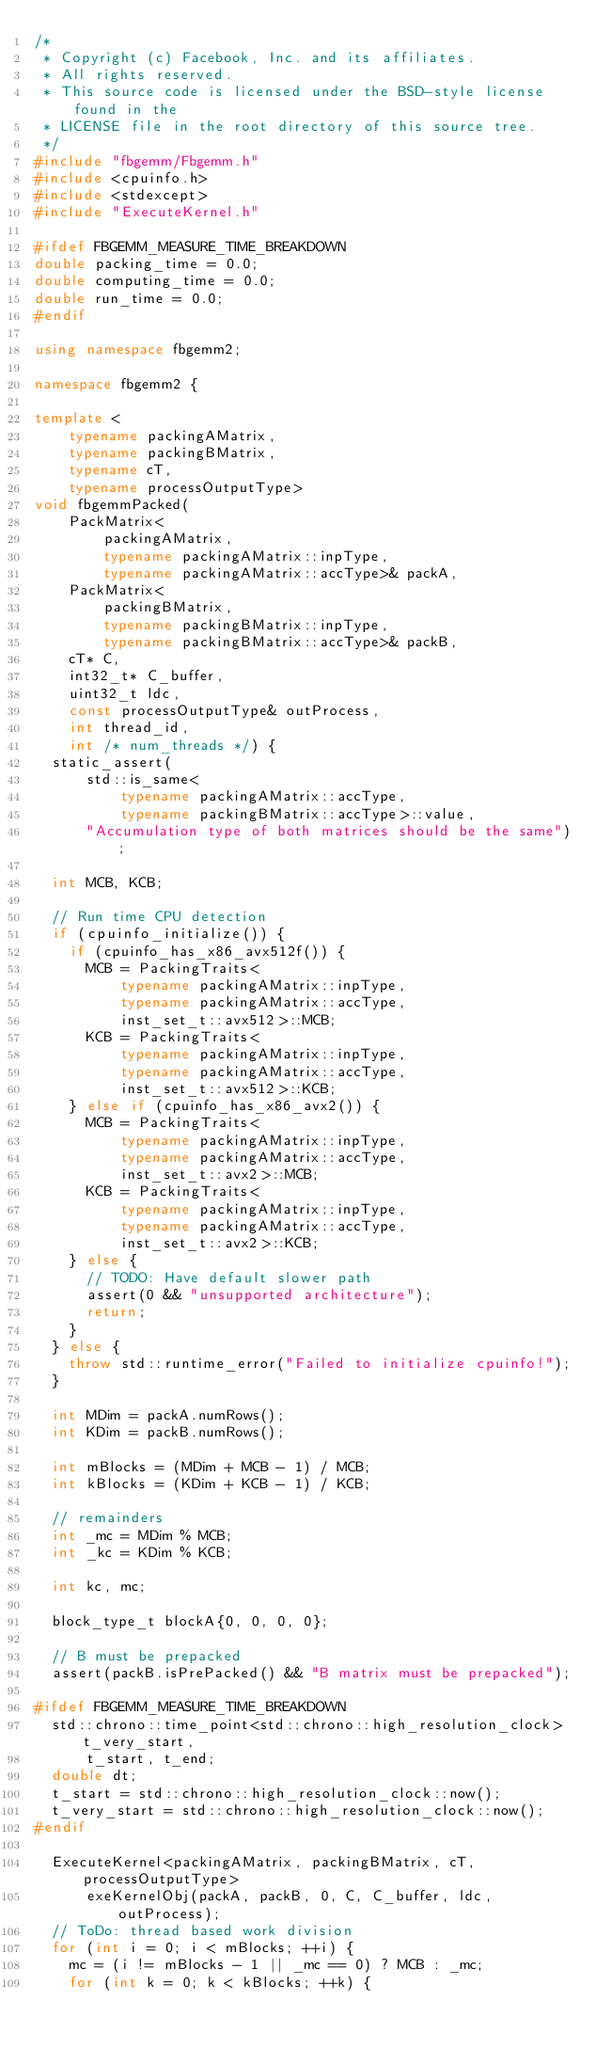<code> <loc_0><loc_0><loc_500><loc_500><_C++_>/*
 * Copyright (c) Facebook, Inc. and its affiliates.
 * All rights reserved.
 * This source code is licensed under the BSD-style license found in the
 * LICENSE file in the root directory of this source tree.
 */
#include "fbgemm/Fbgemm.h"
#include <cpuinfo.h>
#include <stdexcept>
#include "ExecuteKernel.h"

#ifdef FBGEMM_MEASURE_TIME_BREAKDOWN
double packing_time = 0.0;
double computing_time = 0.0;
double run_time = 0.0;
#endif

using namespace fbgemm2;

namespace fbgemm2 {

template <
    typename packingAMatrix,
    typename packingBMatrix,
    typename cT,
    typename processOutputType>
void fbgemmPacked(
    PackMatrix<
        packingAMatrix,
        typename packingAMatrix::inpType,
        typename packingAMatrix::accType>& packA,
    PackMatrix<
        packingBMatrix,
        typename packingBMatrix::inpType,
        typename packingBMatrix::accType>& packB,
    cT* C,
    int32_t* C_buffer,
    uint32_t ldc,
    const processOutputType& outProcess,
    int thread_id,
    int /* num_threads */) {
  static_assert(
      std::is_same<
          typename packingAMatrix::accType,
          typename packingBMatrix::accType>::value,
      "Accumulation type of both matrices should be the same");

  int MCB, KCB;

  // Run time CPU detection
  if (cpuinfo_initialize()) {
    if (cpuinfo_has_x86_avx512f()) {
      MCB = PackingTraits<
          typename packingAMatrix::inpType,
          typename packingAMatrix::accType,
          inst_set_t::avx512>::MCB;
      KCB = PackingTraits<
          typename packingAMatrix::inpType,
          typename packingAMatrix::accType,
          inst_set_t::avx512>::KCB;
    } else if (cpuinfo_has_x86_avx2()) {
      MCB = PackingTraits<
          typename packingAMatrix::inpType,
          typename packingAMatrix::accType,
          inst_set_t::avx2>::MCB;
      KCB = PackingTraits<
          typename packingAMatrix::inpType,
          typename packingAMatrix::accType,
          inst_set_t::avx2>::KCB;
    } else {
      // TODO: Have default slower path
      assert(0 && "unsupported architecture");
      return;
    }
  } else {
    throw std::runtime_error("Failed to initialize cpuinfo!");
  }

  int MDim = packA.numRows();
  int KDim = packB.numRows();

  int mBlocks = (MDim + MCB - 1) / MCB;
  int kBlocks = (KDim + KCB - 1) / KCB;

  // remainders
  int _mc = MDim % MCB;
  int _kc = KDim % KCB;

  int kc, mc;

  block_type_t blockA{0, 0, 0, 0};

  // B must be prepacked
  assert(packB.isPrePacked() && "B matrix must be prepacked");

#ifdef FBGEMM_MEASURE_TIME_BREAKDOWN
  std::chrono::time_point<std::chrono::high_resolution_clock> t_very_start,
      t_start, t_end;
  double dt;
  t_start = std::chrono::high_resolution_clock::now();
  t_very_start = std::chrono::high_resolution_clock::now();
#endif

  ExecuteKernel<packingAMatrix, packingBMatrix, cT, processOutputType>
      exeKernelObj(packA, packB, 0, C, C_buffer, ldc, outProcess);
  // ToDo: thread based work division
  for (int i = 0; i < mBlocks; ++i) {
    mc = (i != mBlocks - 1 || _mc == 0) ? MCB : _mc;
    for (int k = 0; k < kBlocks; ++k) {</code> 